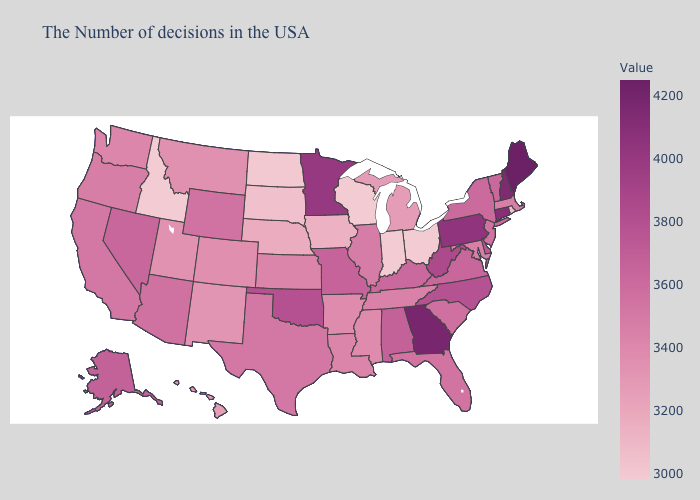Does Wisconsin have the lowest value in the USA?
Keep it brief. Yes. Among the states that border Indiana , does Kentucky have the highest value?
Give a very brief answer. Yes. Does Arizona have the highest value in the USA?
Concise answer only. No. Does Tennessee have a lower value than Oklahoma?
Quick response, please. Yes. Is the legend a continuous bar?
Be succinct. Yes. Does Texas have the lowest value in the South?
Give a very brief answer. No. Does Alaska have the highest value in the West?
Give a very brief answer. Yes. Among the states that border Kentucky , which have the highest value?
Short answer required. West Virginia. 